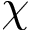Convert formula to latex. <formula><loc_0><loc_0><loc_500><loc_500>\chi</formula> 